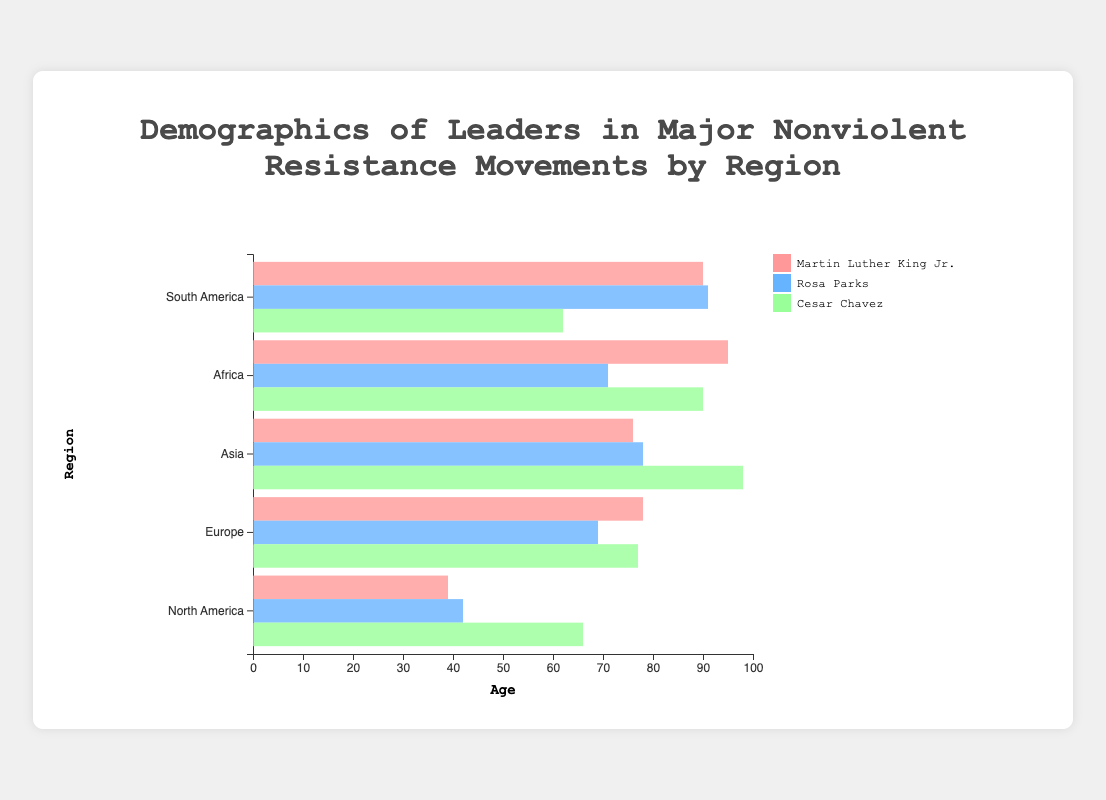How many leaders in North America have a high school education level? There are two leaders listed in North America with "High School" as their education level: Rosa Parks and Cesar Chavez. This can be verified by observing the education level data for each individual listed under the "North America" region.
Answer: 2 Which region has the oldest leader and what is their age? The oldest leader is in the Asia region, which is Khan Abdul Ghaffar Khan with an age of 98. This can be identified by checking the age of the oldest leader among all regions in the chart.
Answer: Asia, 98 Compare the education levels of the leaders in Europe and identify how many distinct education levels are present. In Europe, the leaders have education levels of "Law Degree" (Mahatma Gandhi), "College" (Emmeline Pankhurst), and "Technical School" (Lech Wałęsa). This results in three distinct education levels: Law Degree, College, and Technical School.
Answer: 3 Which region has the highest proportion of female leaders? To determine the region with the highest proportion of female leaders, count the number of female leaders and compare it against the total number of leaders within each region. North America and Africa have 1 female out of 3 leaders, Europe has 1 female out of 3, Asia has 1 female out of 3 leaders, and South America has 1 female out of 3. Since the proportions are equal across regions, all regions have the same proportion of female leaders.
Answer: All regions have the same proportion Which leader listed in South America has the highest age and what is their age? In South America, the leader with the highest age is Adolfo Pérez Esquivel with an age of 91. This can be identified by checking the ages of the leaders listed under the "South America" region.
Answer: Adolfo Pérez Esquivel, 91 What is the average age of the leaders in Africa? The ages of the leaders in Africa are: Nelson Mandela (95), Waangari Maathai (71), and Desmond Tutu (90). To find the average age: (95 + 71 + 90) / 3 = 256 / 3 ≈ 85.33. Therefore, the average age is approximately 85.33.
Answer: 85.33 Identify the region with the leader having the doctorate degree and the lowest age. The regions with leaders having doctorate degrees are North America (Martin Luther King Jr., age 39) and Africa (Waangari Maathai, age 71). Among these, Martin Luther King Jr. from North America has the lowest age at 39.
Answer: North America, 39 